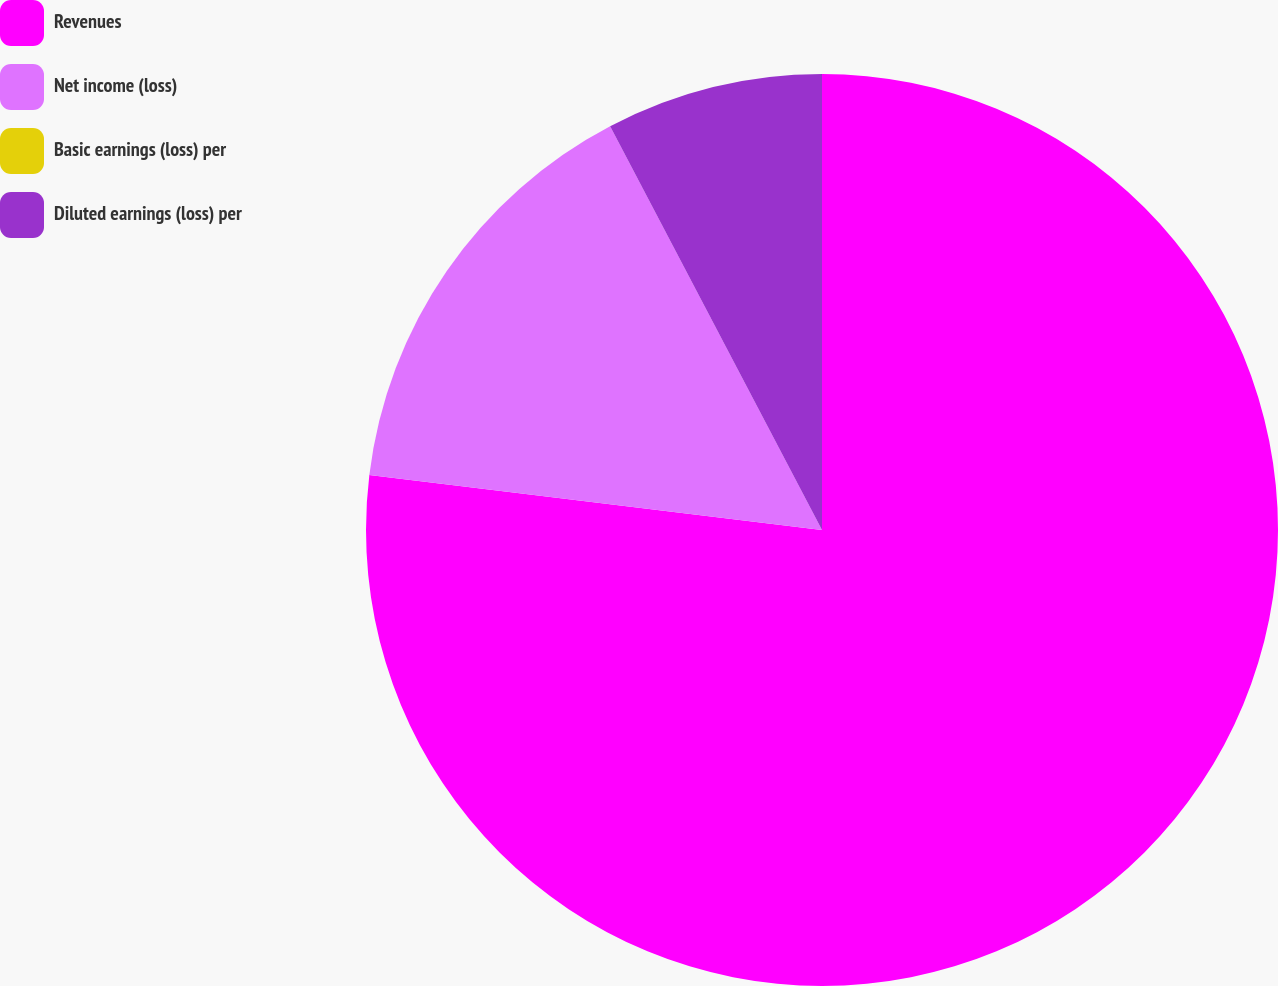<chart> <loc_0><loc_0><loc_500><loc_500><pie_chart><fcel>Revenues<fcel>Net income (loss)<fcel>Basic earnings (loss) per<fcel>Diluted earnings (loss) per<nl><fcel>76.92%<fcel>15.38%<fcel>0.0%<fcel>7.69%<nl></chart> 